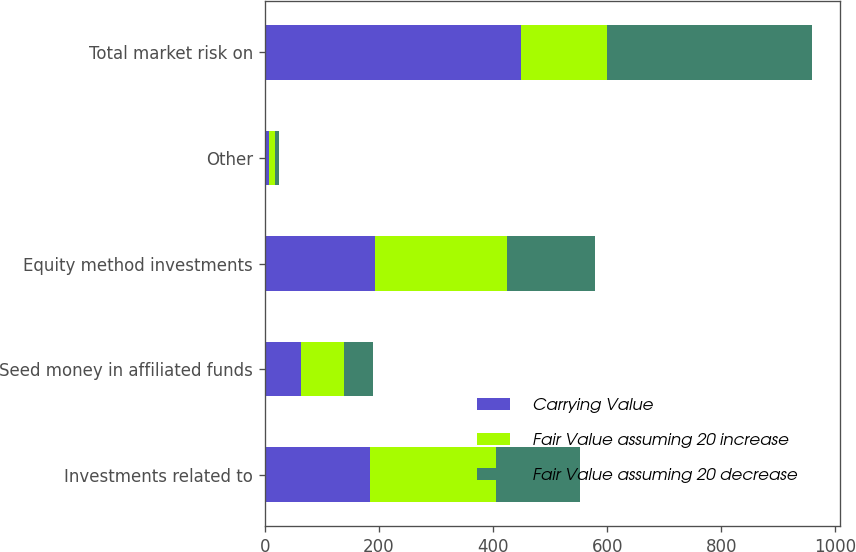Convert chart. <chart><loc_0><loc_0><loc_500><loc_500><stacked_bar_chart><ecel><fcel>Investments related to<fcel>Seed money in affiliated funds<fcel>Equity method investments<fcel>Other<fcel>Total market risk on<nl><fcel>Carrying Value<fcel>184.4<fcel>63.5<fcel>193.1<fcel>8.2<fcel>449.2<nl><fcel>Fair Value assuming 20 increase<fcel>221.3<fcel>76.2<fcel>231.7<fcel>9.8<fcel>151<nl><fcel>Fair Value assuming 20 decrease<fcel>147.5<fcel>50.8<fcel>154.5<fcel>6.6<fcel>359.4<nl></chart> 